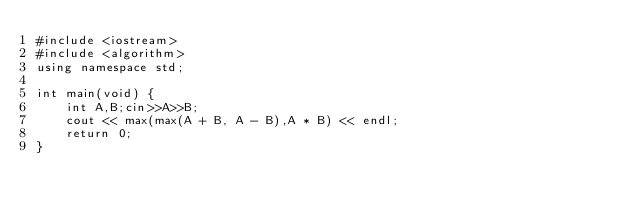<code> <loc_0><loc_0><loc_500><loc_500><_C++_>#include <iostream>
#include <algorithm>
using namespace std;

int main(void) {
    int A,B;cin>>A>>B;
    cout << max(max(A + B, A - B),A * B) << endl;
    return 0;
}</code> 